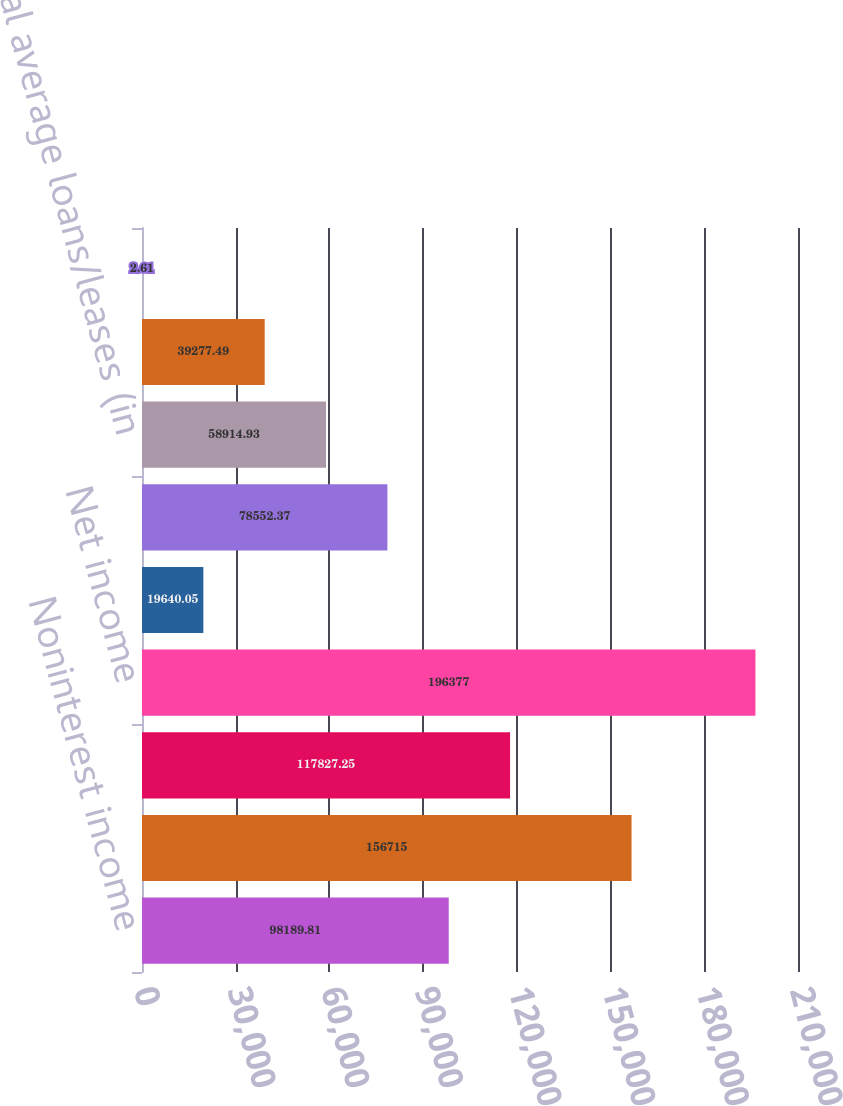Convert chart. <chart><loc_0><loc_0><loc_500><loc_500><bar_chart><fcel>Noninterest income<fcel>Noninterest expense<fcel>Provision for income taxes<fcel>Net income<fcel>Number of employees (average<fcel>Total average assets (in<fcel>Total average loans/leases (in<fcel>Total average deposits (in<fcel>Net interest margin<nl><fcel>98189.8<fcel>156715<fcel>117827<fcel>196377<fcel>19640<fcel>78552.4<fcel>58914.9<fcel>39277.5<fcel>2.61<nl></chart> 